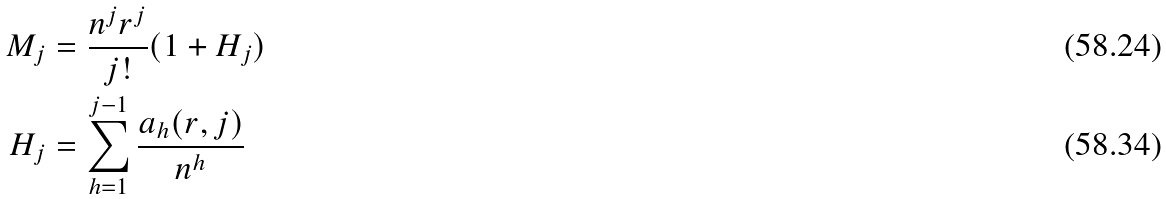<formula> <loc_0><loc_0><loc_500><loc_500>M _ { j } & = \frac { n ^ { j } r ^ { j } } { j ! } ( 1 + H _ { j } ) \\ H _ { j } & = \sum _ { h = 1 } ^ { j - 1 } \frac { a _ { h } ( r , j ) } { n ^ { h } }</formula> 